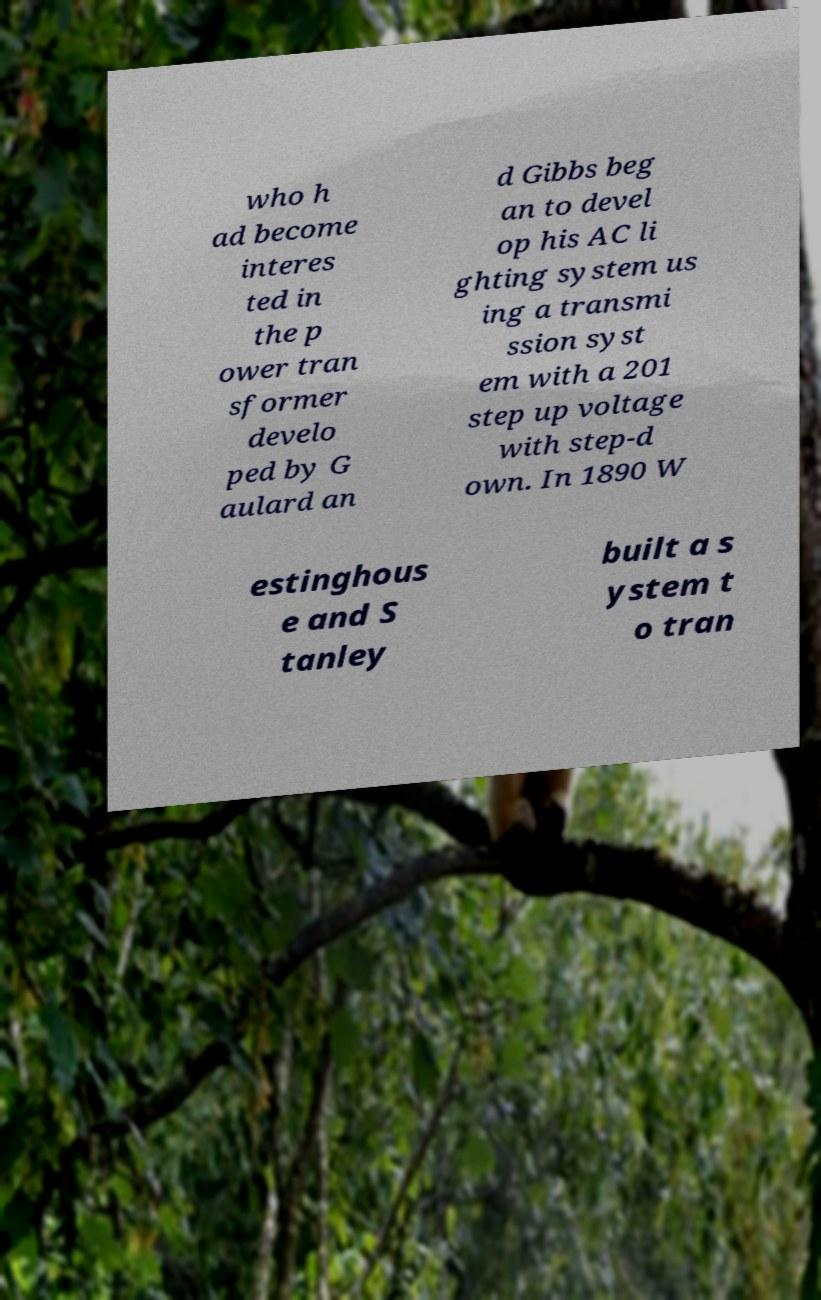Can you read and provide the text displayed in the image?This photo seems to have some interesting text. Can you extract and type it out for me? who h ad become interes ted in the p ower tran sformer develo ped by G aulard an d Gibbs beg an to devel op his AC li ghting system us ing a transmi ssion syst em with a 201 step up voltage with step-d own. In 1890 W estinghous e and S tanley built a s ystem t o tran 